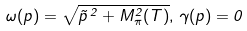Convert formula to latex. <formula><loc_0><loc_0><loc_500><loc_500>\omega ( p ) = \sqrt { \vec { p } \, ^ { 2 } + M _ { \pi } ^ { 2 } ( T ) } , \, \gamma ( p ) = 0</formula> 